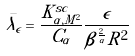<formula> <loc_0><loc_0><loc_500><loc_500>\bar { \lambda _ { \epsilon } } = \frac { K ^ { s c } _ { \alpha , M ^ { 2 } } } { C _ { \alpha } } \frac { \epsilon } { \beta ^ { \frac { 2 } { \alpha } } R ^ { 2 } }</formula> 